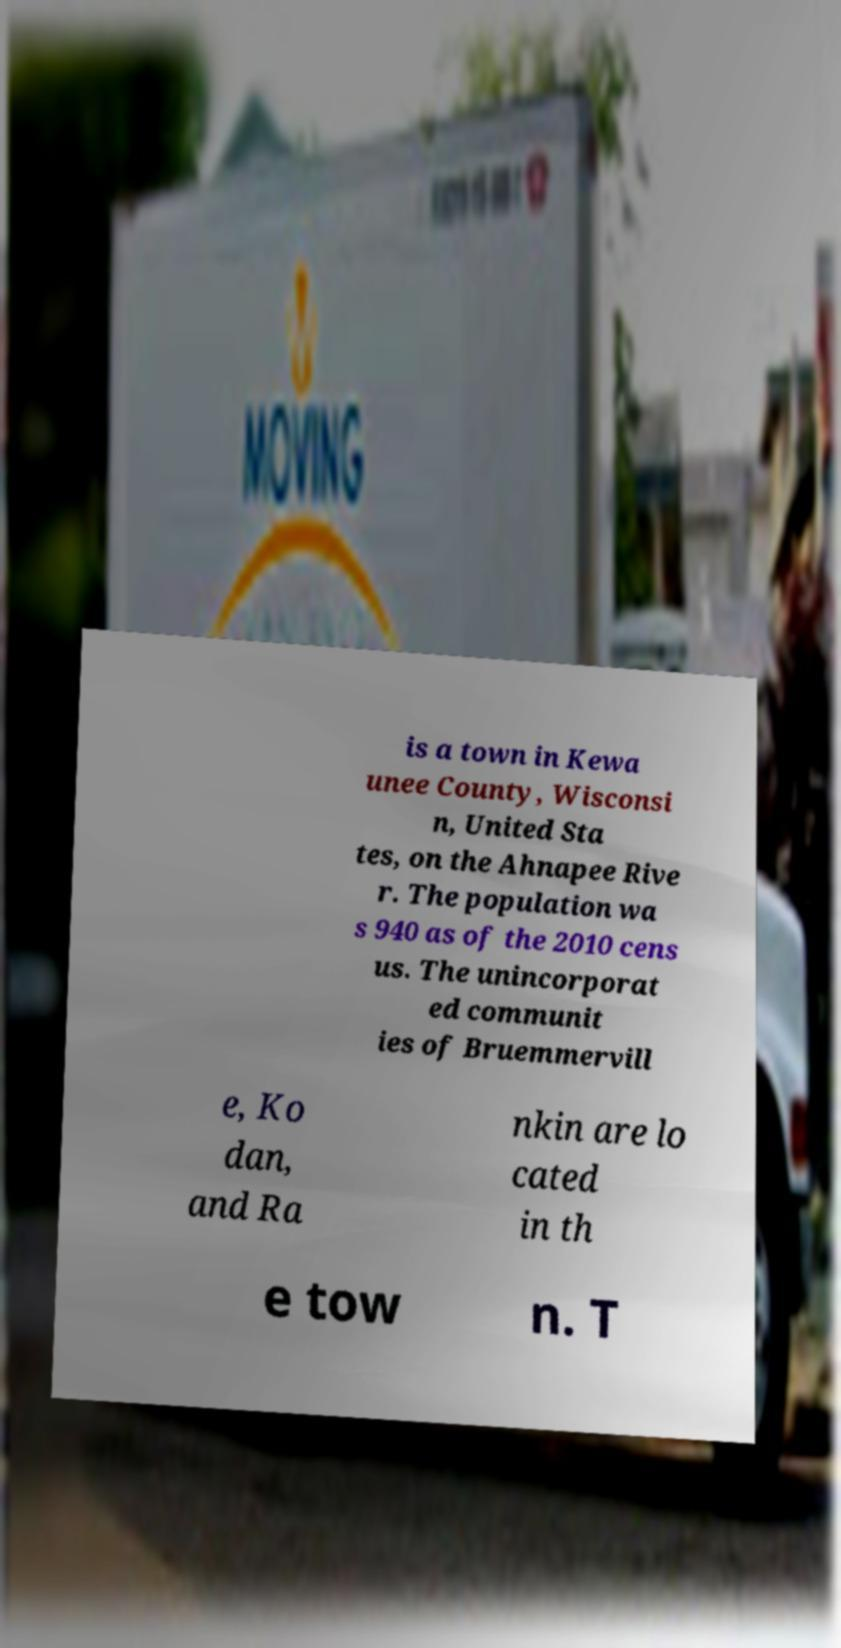Can you read and provide the text displayed in the image?This photo seems to have some interesting text. Can you extract and type it out for me? is a town in Kewa unee County, Wisconsi n, United Sta tes, on the Ahnapee Rive r. The population wa s 940 as of the 2010 cens us. The unincorporat ed communit ies of Bruemmervill e, Ko dan, and Ra nkin are lo cated in th e tow n. T 